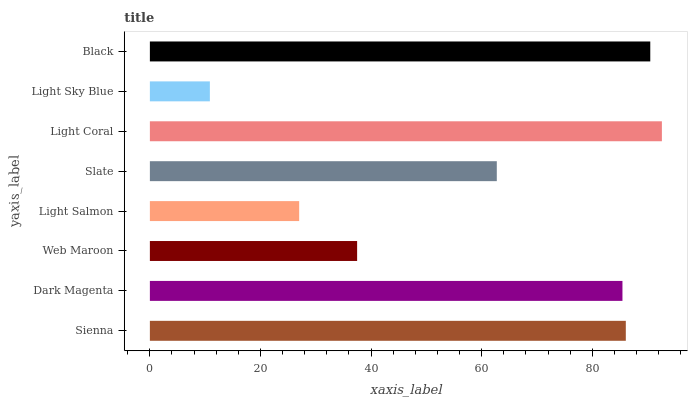Is Light Sky Blue the minimum?
Answer yes or no. Yes. Is Light Coral the maximum?
Answer yes or no. Yes. Is Dark Magenta the minimum?
Answer yes or no. No. Is Dark Magenta the maximum?
Answer yes or no. No. Is Sienna greater than Dark Magenta?
Answer yes or no. Yes. Is Dark Magenta less than Sienna?
Answer yes or no. Yes. Is Dark Magenta greater than Sienna?
Answer yes or no. No. Is Sienna less than Dark Magenta?
Answer yes or no. No. Is Dark Magenta the high median?
Answer yes or no. Yes. Is Slate the low median?
Answer yes or no. Yes. Is Light Sky Blue the high median?
Answer yes or no. No. Is Light Sky Blue the low median?
Answer yes or no. No. 